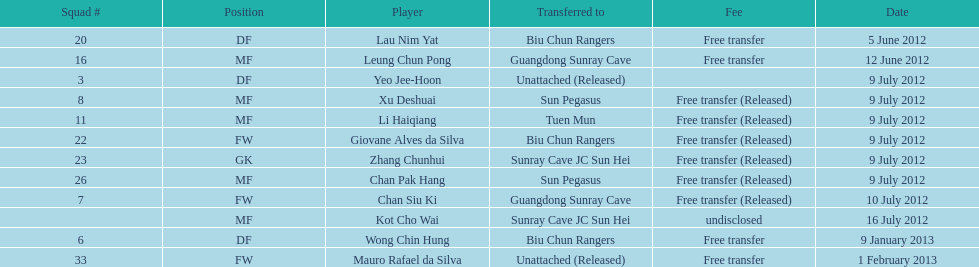After being transferred, which team did lau nim yat join? Biu Chun Rangers. 